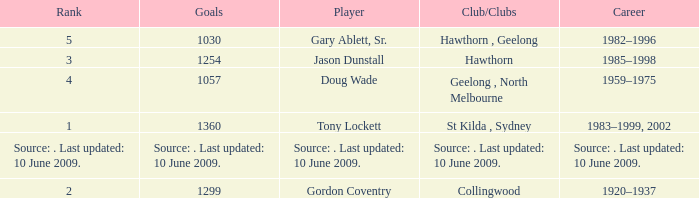What is the rank of player Jason Dunstall? 3.0. 